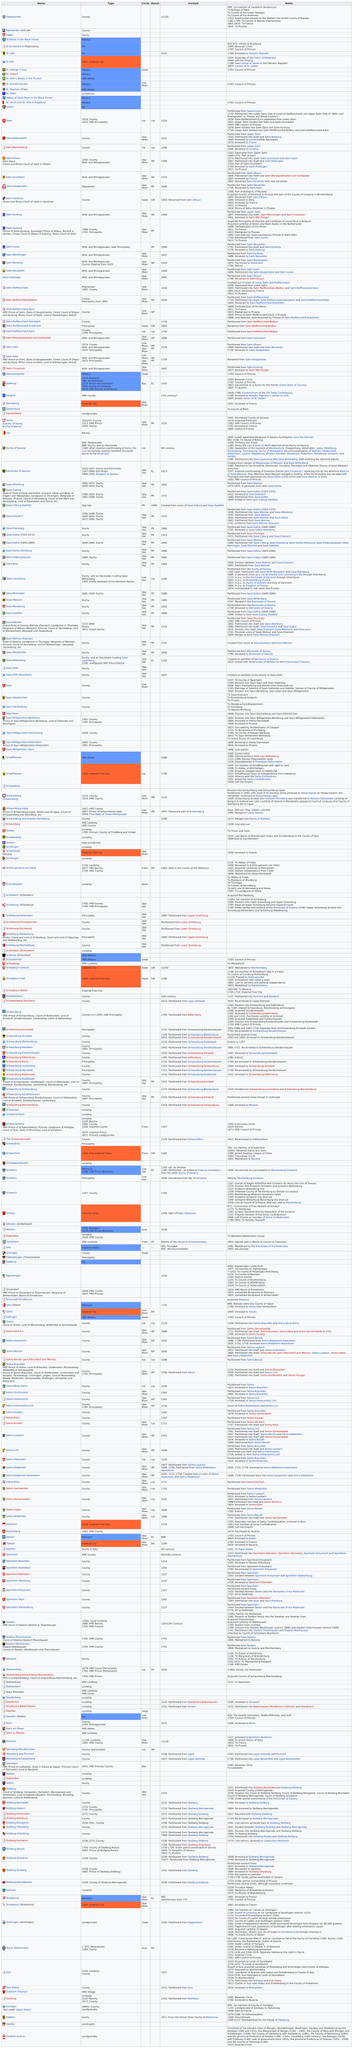Identify some key points in this picture. There were three states that were similar to Stuhlingen. I have successfully located and identified a Sagan, a type of duchy, and they are ready for use. The bench that is most commonly represented is the Progressive Resistance (PR) bench. 